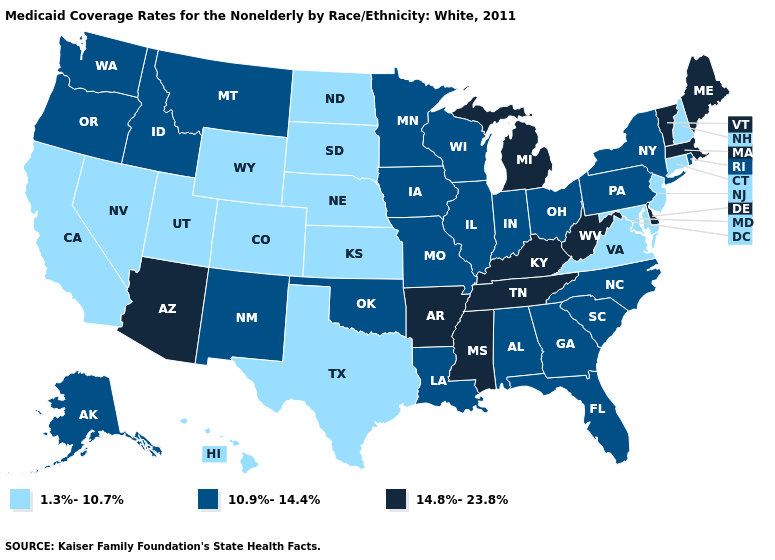What is the value of Utah?
Short answer required. 1.3%-10.7%. Does Alabama have a lower value than Arkansas?
Quick response, please. Yes. Does Mississippi have the lowest value in the South?
Quick response, please. No. What is the value of Idaho?
Quick response, please. 10.9%-14.4%. What is the lowest value in the USA?
Concise answer only. 1.3%-10.7%. Does Maryland have the lowest value in the USA?
Be succinct. Yes. What is the highest value in the Northeast ?
Answer briefly. 14.8%-23.8%. Does South Dakota have the lowest value in the MidWest?
Quick response, please. Yes. Which states hav the highest value in the South?
Quick response, please. Arkansas, Delaware, Kentucky, Mississippi, Tennessee, West Virginia. Name the states that have a value in the range 1.3%-10.7%?
Be succinct. California, Colorado, Connecticut, Hawaii, Kansas, Maryland, Nebraska, Nevada, New Hampshire, New Jersey, North Dakota, South Dakota, Texas, Utah, Virginia, Wyoming. Among the states that border Ohio , which have the highest value?
Short answer required. Kentucky, Michigan, West Virginia. Among the states that border Wisconsin , which have the highest value?
Short answer required. Michigan. What is the lowest value in the MidWest?
Write a very short answer. 1.3%-10.7%. What is the value of Missouri?
Concise answer only. 10.9%-14.4%. What is the lowest value in the MidWest?
Keep it brief. 1.3%-10.7%. 